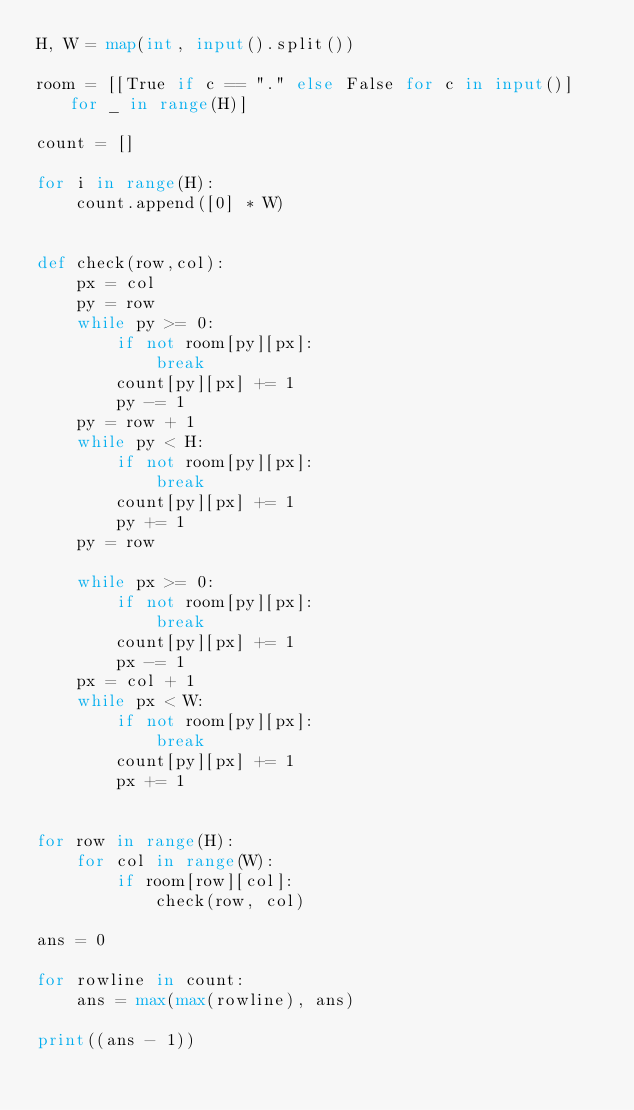Convert code to text. <code><loc_0><loc_0><loc_500><loc_500><_Python_>H, W = map(int, input().split())

room = [[True if c == "." else False for c in input()] for _ in range(H)]

count = []

for i in range(H):
    count.append([0] * W)


def check(row,col):
    px = col
    py = row
    while py >= 0:
        if not room[py][px]:
            break
        count[py][px] += 1
        py -= 1
    py = row + 1
    while py < H:
        if not room[py][px]:
            break
        count[py][px] += 1
        py += 1
    py = row

    while px >= 0:
        if not room[py][px]:
            break
        count[py][px] += 1
        px -= 1
    px = col + 1
    while px < W:
        if not room[py][px]:
            break
        count[py][px] += 1
        px += 1


for row in range(H):
    for col in range(W):
        if room[row][col]:
            check(row, col)

ans = 0

for rowline in count:
    ans = max(max(rowline), ans)

print((ans - 1))</code> 